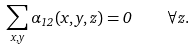<formula> <loc_0><loc_0><loc_500><loc_500>\sum _ { x , y } \alpha _ { 1 2 } ( x , y , z ) = 0 \quad \forall z .</formula> 